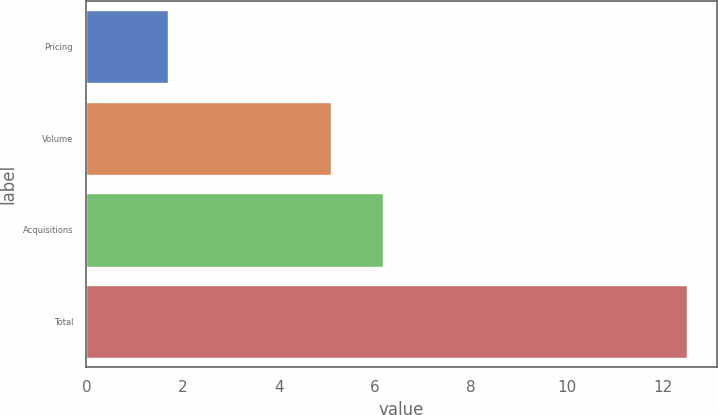Convert chart. <chart><loc_0><loc_0><loc_500><loc_500><bar_chart><fcel>Pricing<fcel>Volume<fcel>Acquisitions<fcel>Total<nl><fcel>1.7<fcel>5.1<fcel>6.18<fcel>12.5<nl></chart> 